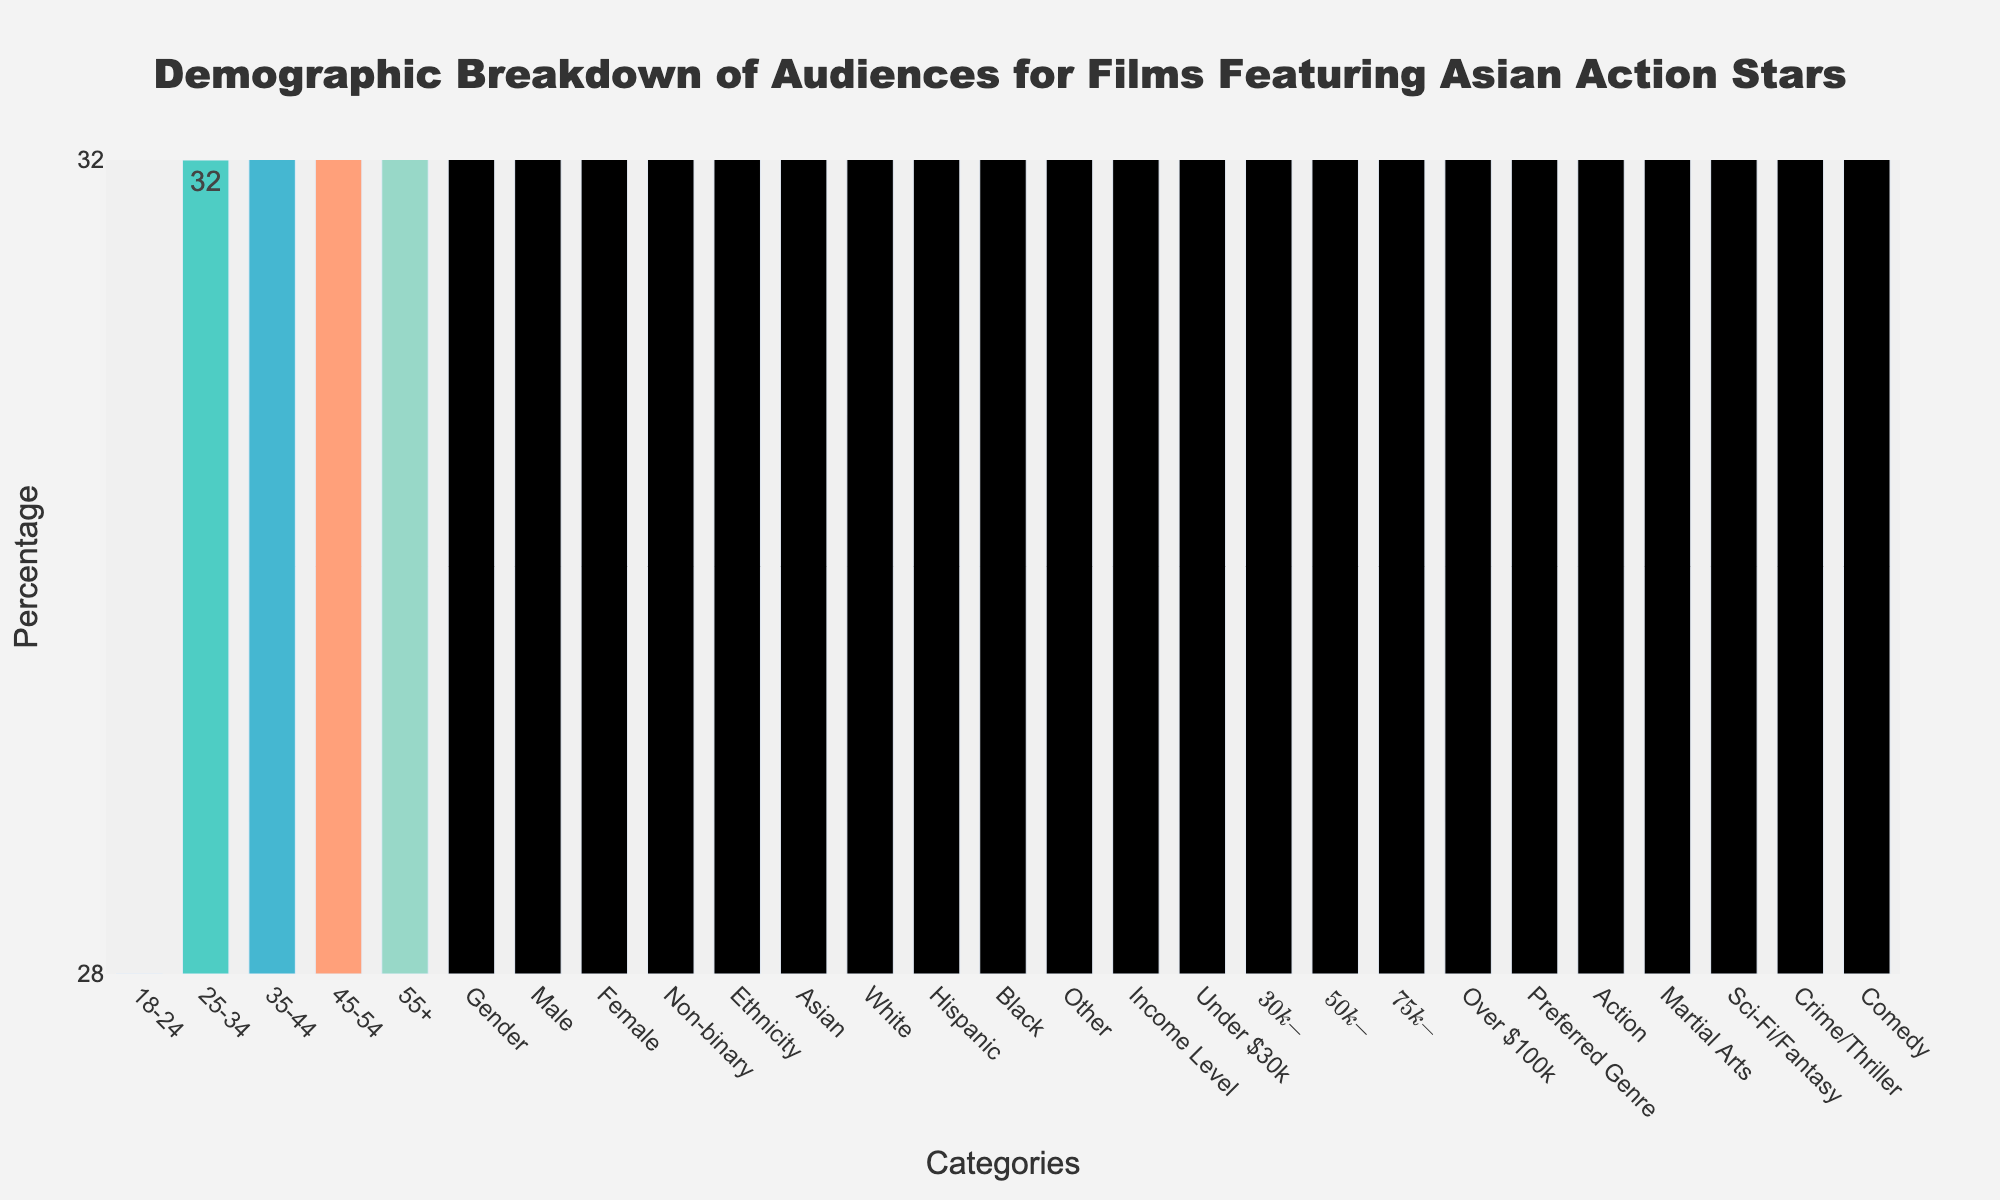What is the percentage difference between the age groups 18-24 and 55+? To find the percentage difference, subtract the percentage of the 55+ age group from the 18-24 age group: 28% - 6% = 22%.
Answer: 22% Which gender has the highest representation? The bar for male shows the highest percentage compared to female and non-binary, with 58%.
Answer: Male How many more percent of the audience is Asian compared to Hispanic? Subtract the percentage of Hispanic from Asian: 45% - 15% = 30%.
Answer: 30% What is the total percentage of audiences that are either female or non-binary? Add the percentages of female and non-binary: 41% + 1% = 42%.
Answer: 42% Which income level has the highest representation? The bar representing the $50k-$75k income level is the tallest among all income levels, indicating the highest percentage at 30%.
Answer: $50k-$75k How does the popularity of the Action genre compare to Comedy among audiences? The bar for Action is much taller than Comedy, showing Action at 40% and Comedy at 8%.
Answer: Action is 32% higher than Comedy What is the average percentage of audiences from the age groups 25-34 and 35-44? Add the percentages of the 25-34 and 35-44 age groups and divide by 2: (32% + 22%) / 2 = 27%.
Answer: 27% What percentage of the audience does not identify as male or female? Add the percentages of non-binary: 1%.
Answer: 1% Is the percentage of Asian audiences more or less than the combined percentages of Black and Hispanic audiences? Add the percentages of Black and Hispanic audiences: 8% + 15% = 23%. The percentage of Asian audiences is higher at 45%.
Answer: More What's the median value of the preferred genres? To find the median, list the preferred genres' percentages in order: 8%, 12%, 15%, 25%, 40%. The median is the middle value, which is 15% (Sci-Fi/Fantasy).
Answer: 15% 